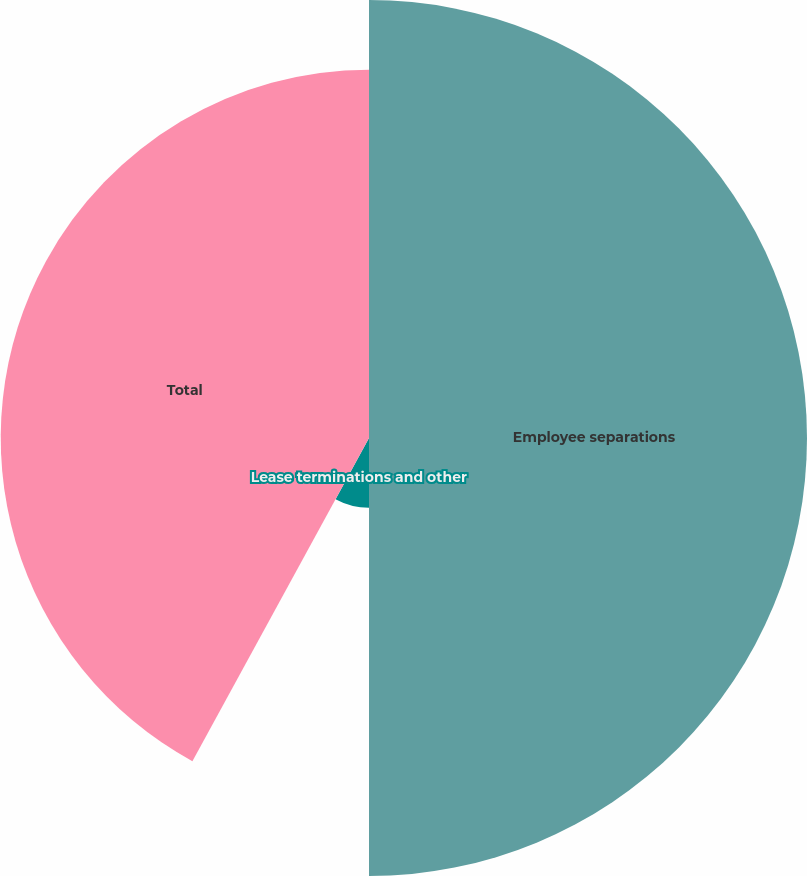Convert chart to OTSL. <chart><loc_0><loc_0><loc_500><loc_500><pie_chart><fcel>Employee separations<fcel>Lease terminations and other<fcel>Total<nl><fcel>50.0%<fcel>7.96%<fcel>42.04%<nl></chart> 